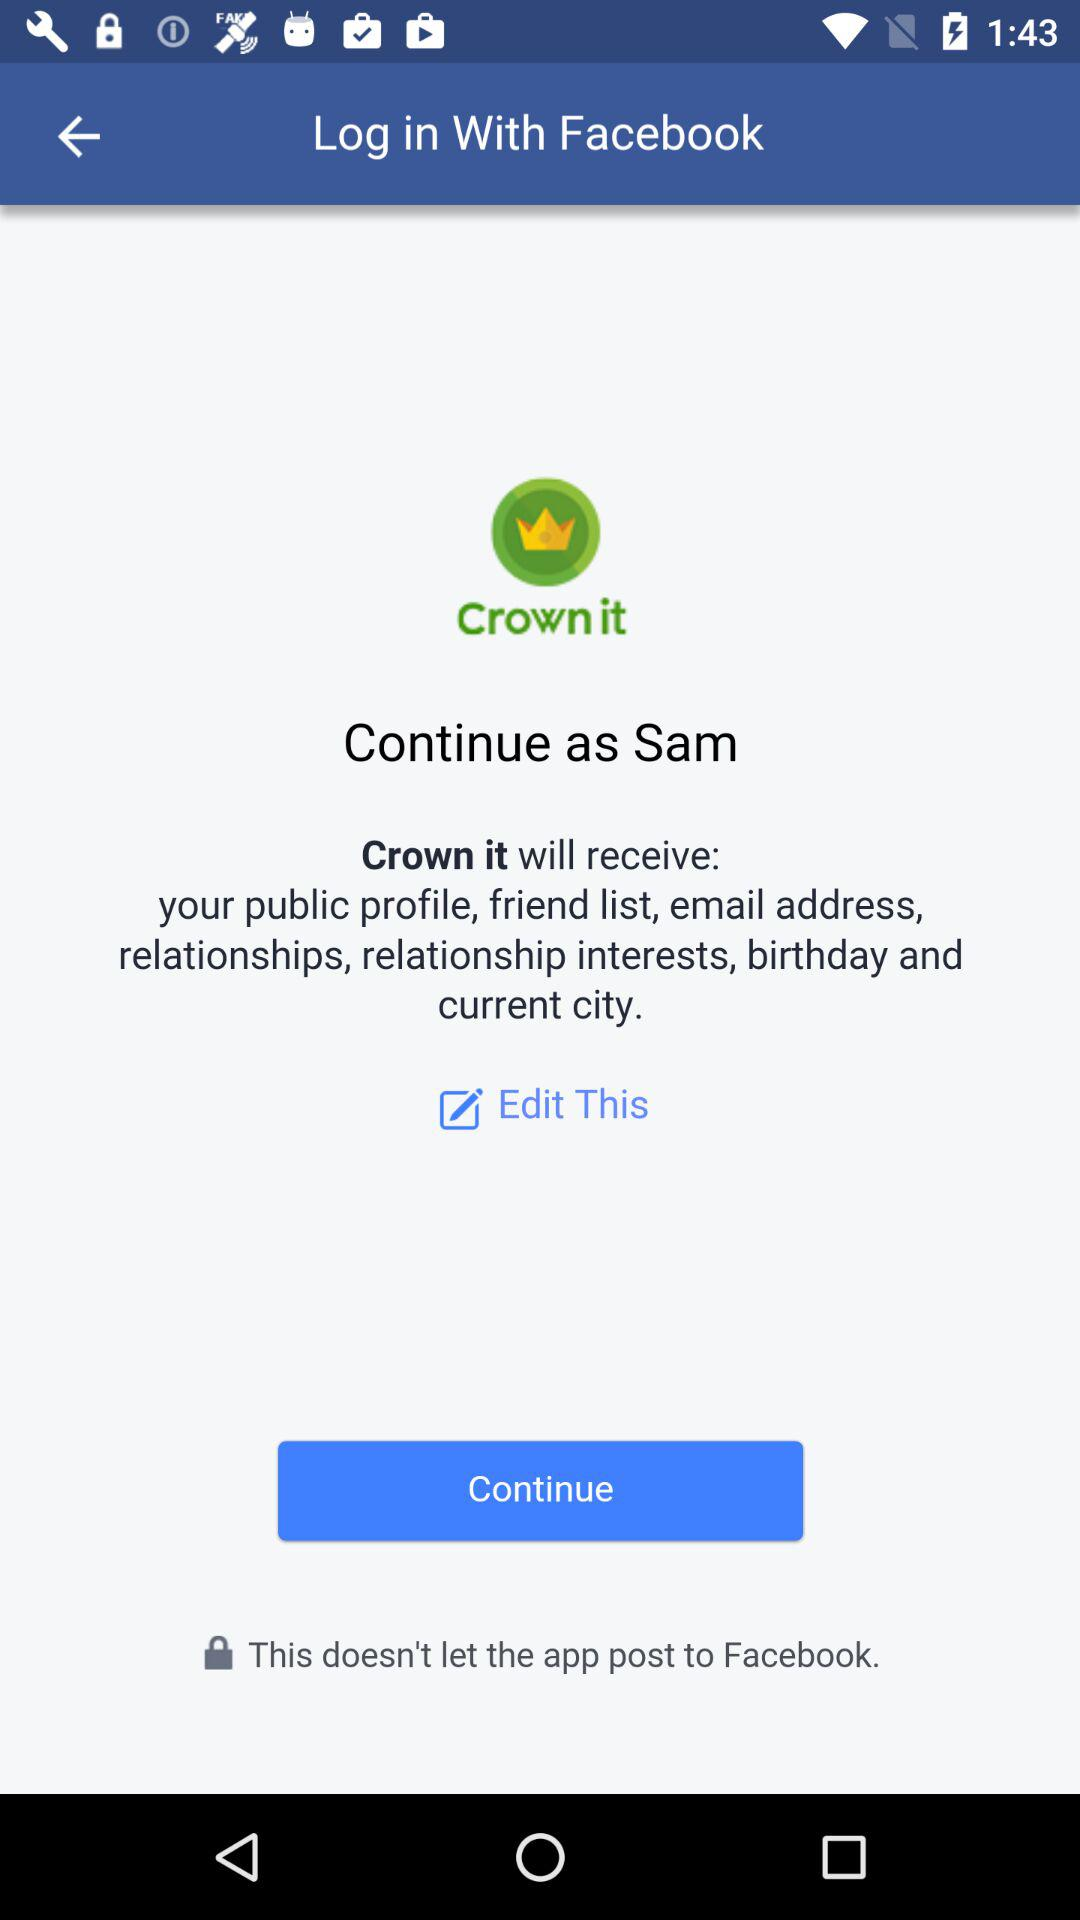What application is used to log in? The application used to log in is "Facebook". 